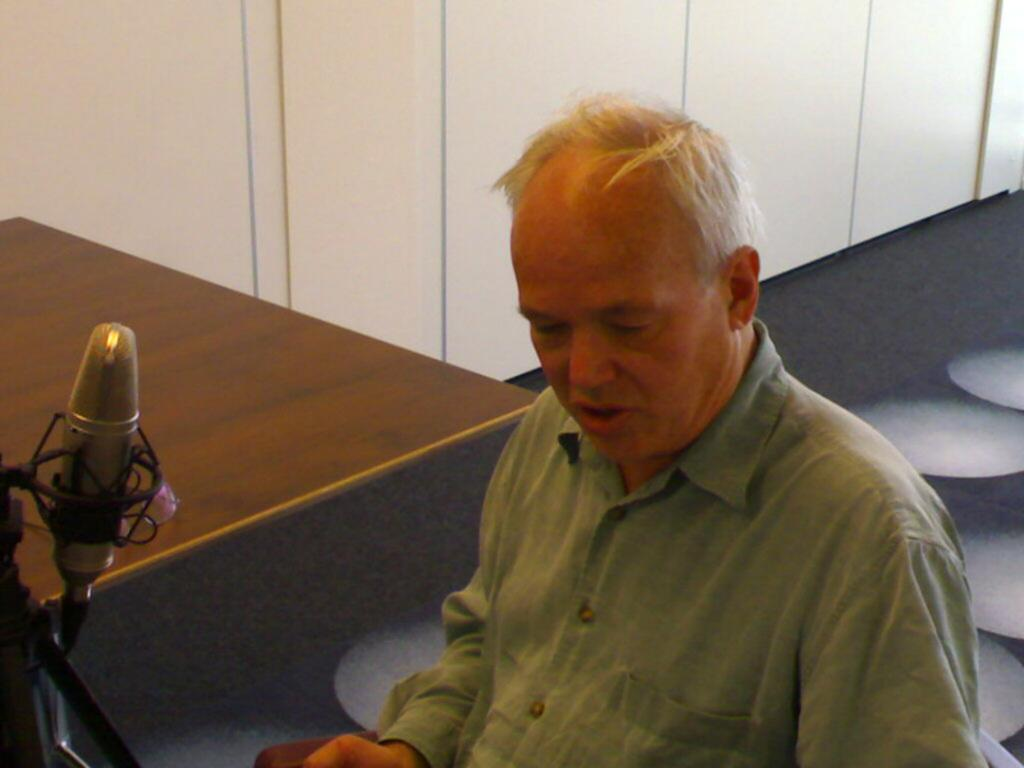What is the main subject of the image? There is a man in the image. What is the man wearing in the image? The man is wearing a green shirt. What type of furniture is present in the image? There is a wooden table in the image. What can be seen on the left side of the image? There is a mic on the left side of the image. What is visible in the background of the image? There is a wall in the background of the image, and the floor is black. What type of cough does the man have in the image? There is no indication of a cough in the image; the man is simply standing and wearing a green shirt. Can you tell me the name of the man's parent in the image? There is no information about the man's parent in the image, as it only shows the man standing and wearing a green shirt. 